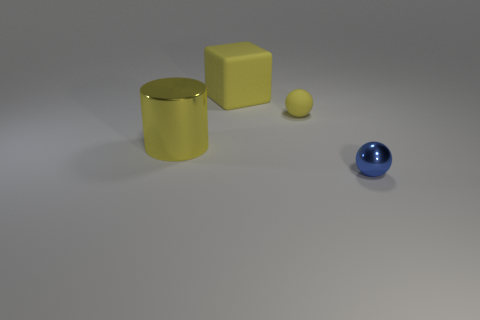Is there anything else that has the same size as the cylinder? The yellow cube appears to have similar dimensions in height and width to the cylinder, though without exact measurements it cannot be confirmed if they are of the exact same size. The sphere and the smaller object to the left of the cube are visibly smaller than the cylinder. 